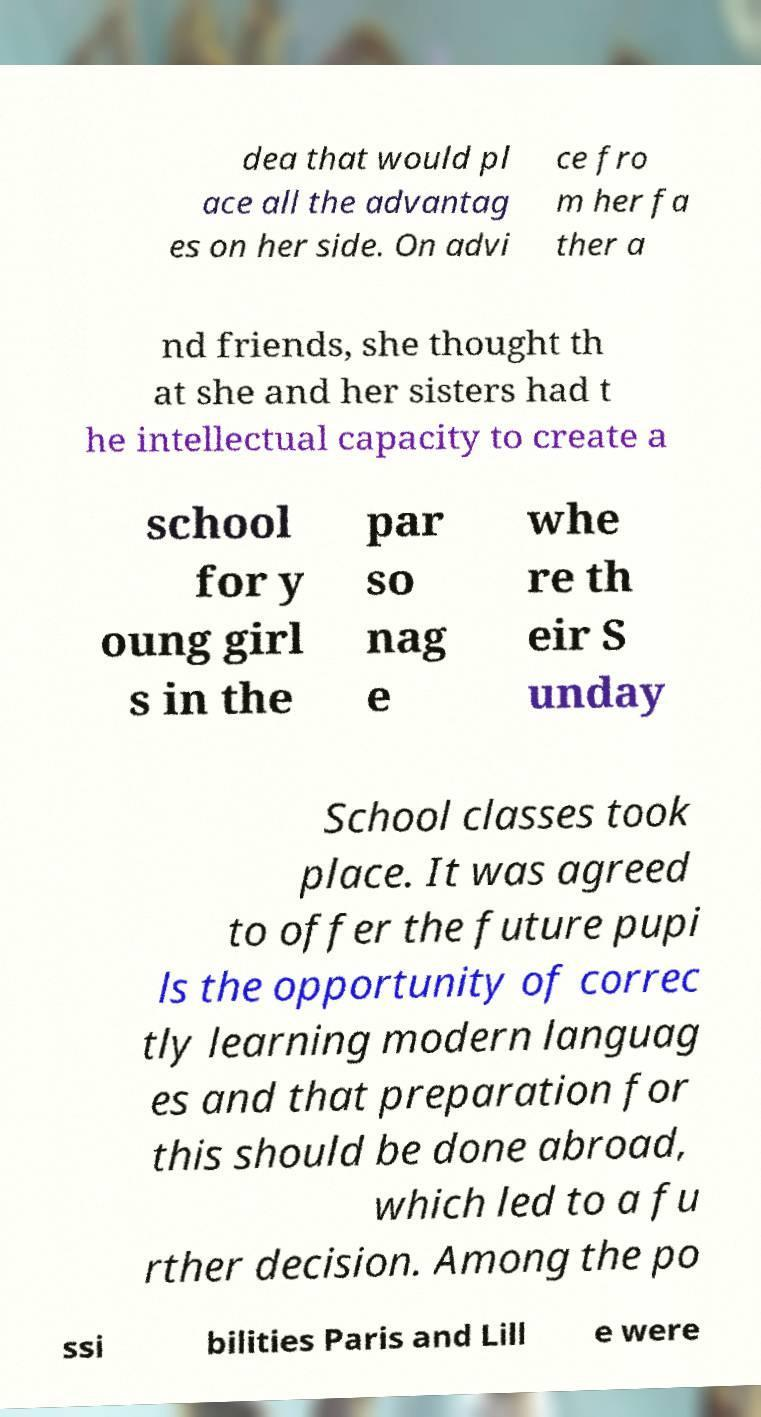Could you extract and type out the text from this image? dea that would pl ace all the advantag es on her side. On advi ce fro m her fa ther a nd friends, she thought th at she and her sisters had t he intellectual capacity to create a school for y oung girl s in the par so nag e whe re th eir S unday School classes took place. It was agreed to offer the future pupi ls the opportunity of correc tly learning modern languag es and that preparation for this should be done abroad, which led to a fu rther decision. Among the po ssi bilities Paris and Lill e were 